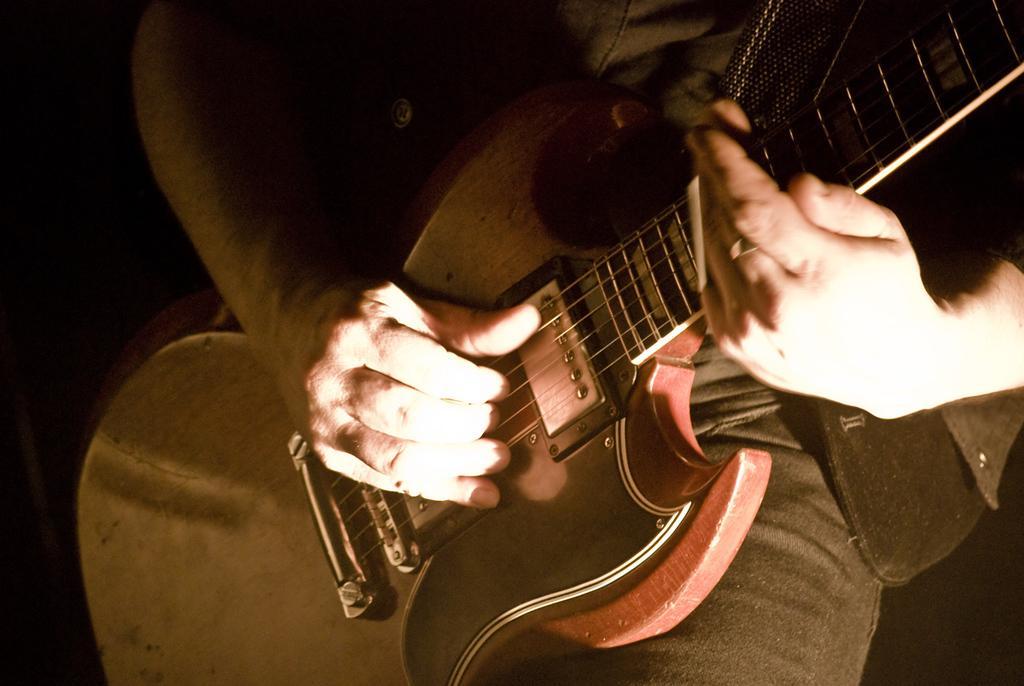Can you describe this image briefly? In this image we can see a person holding a guitar in his hand. 